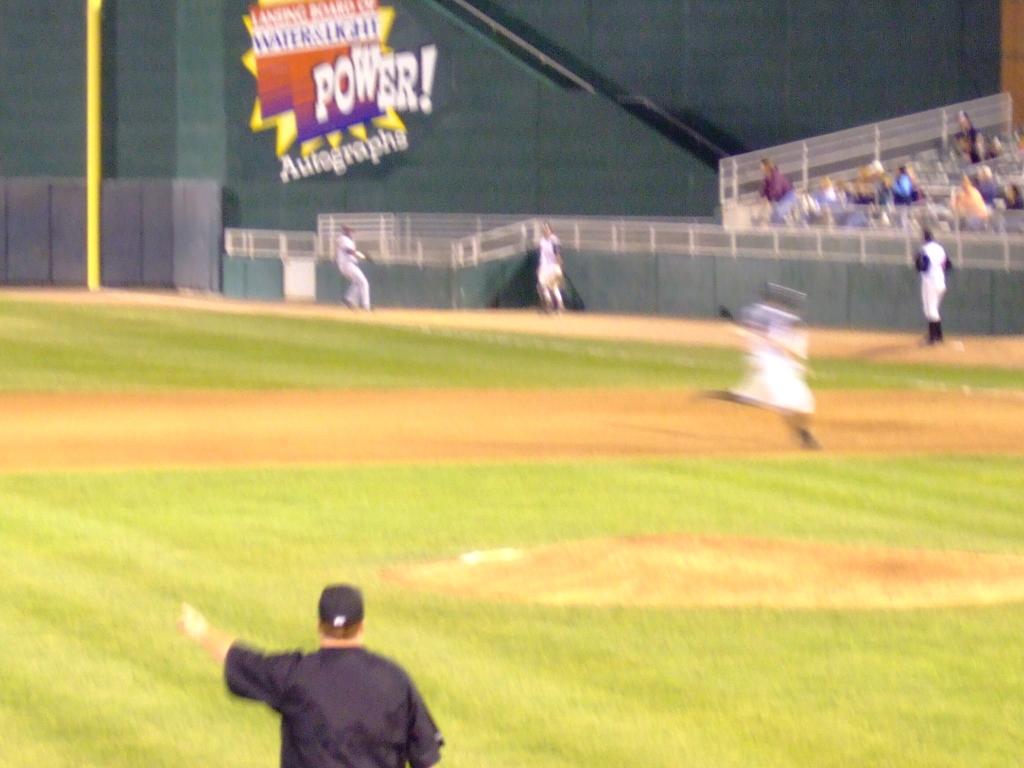What does it say under "power!"?
Give a very brief answer. Autographs. 